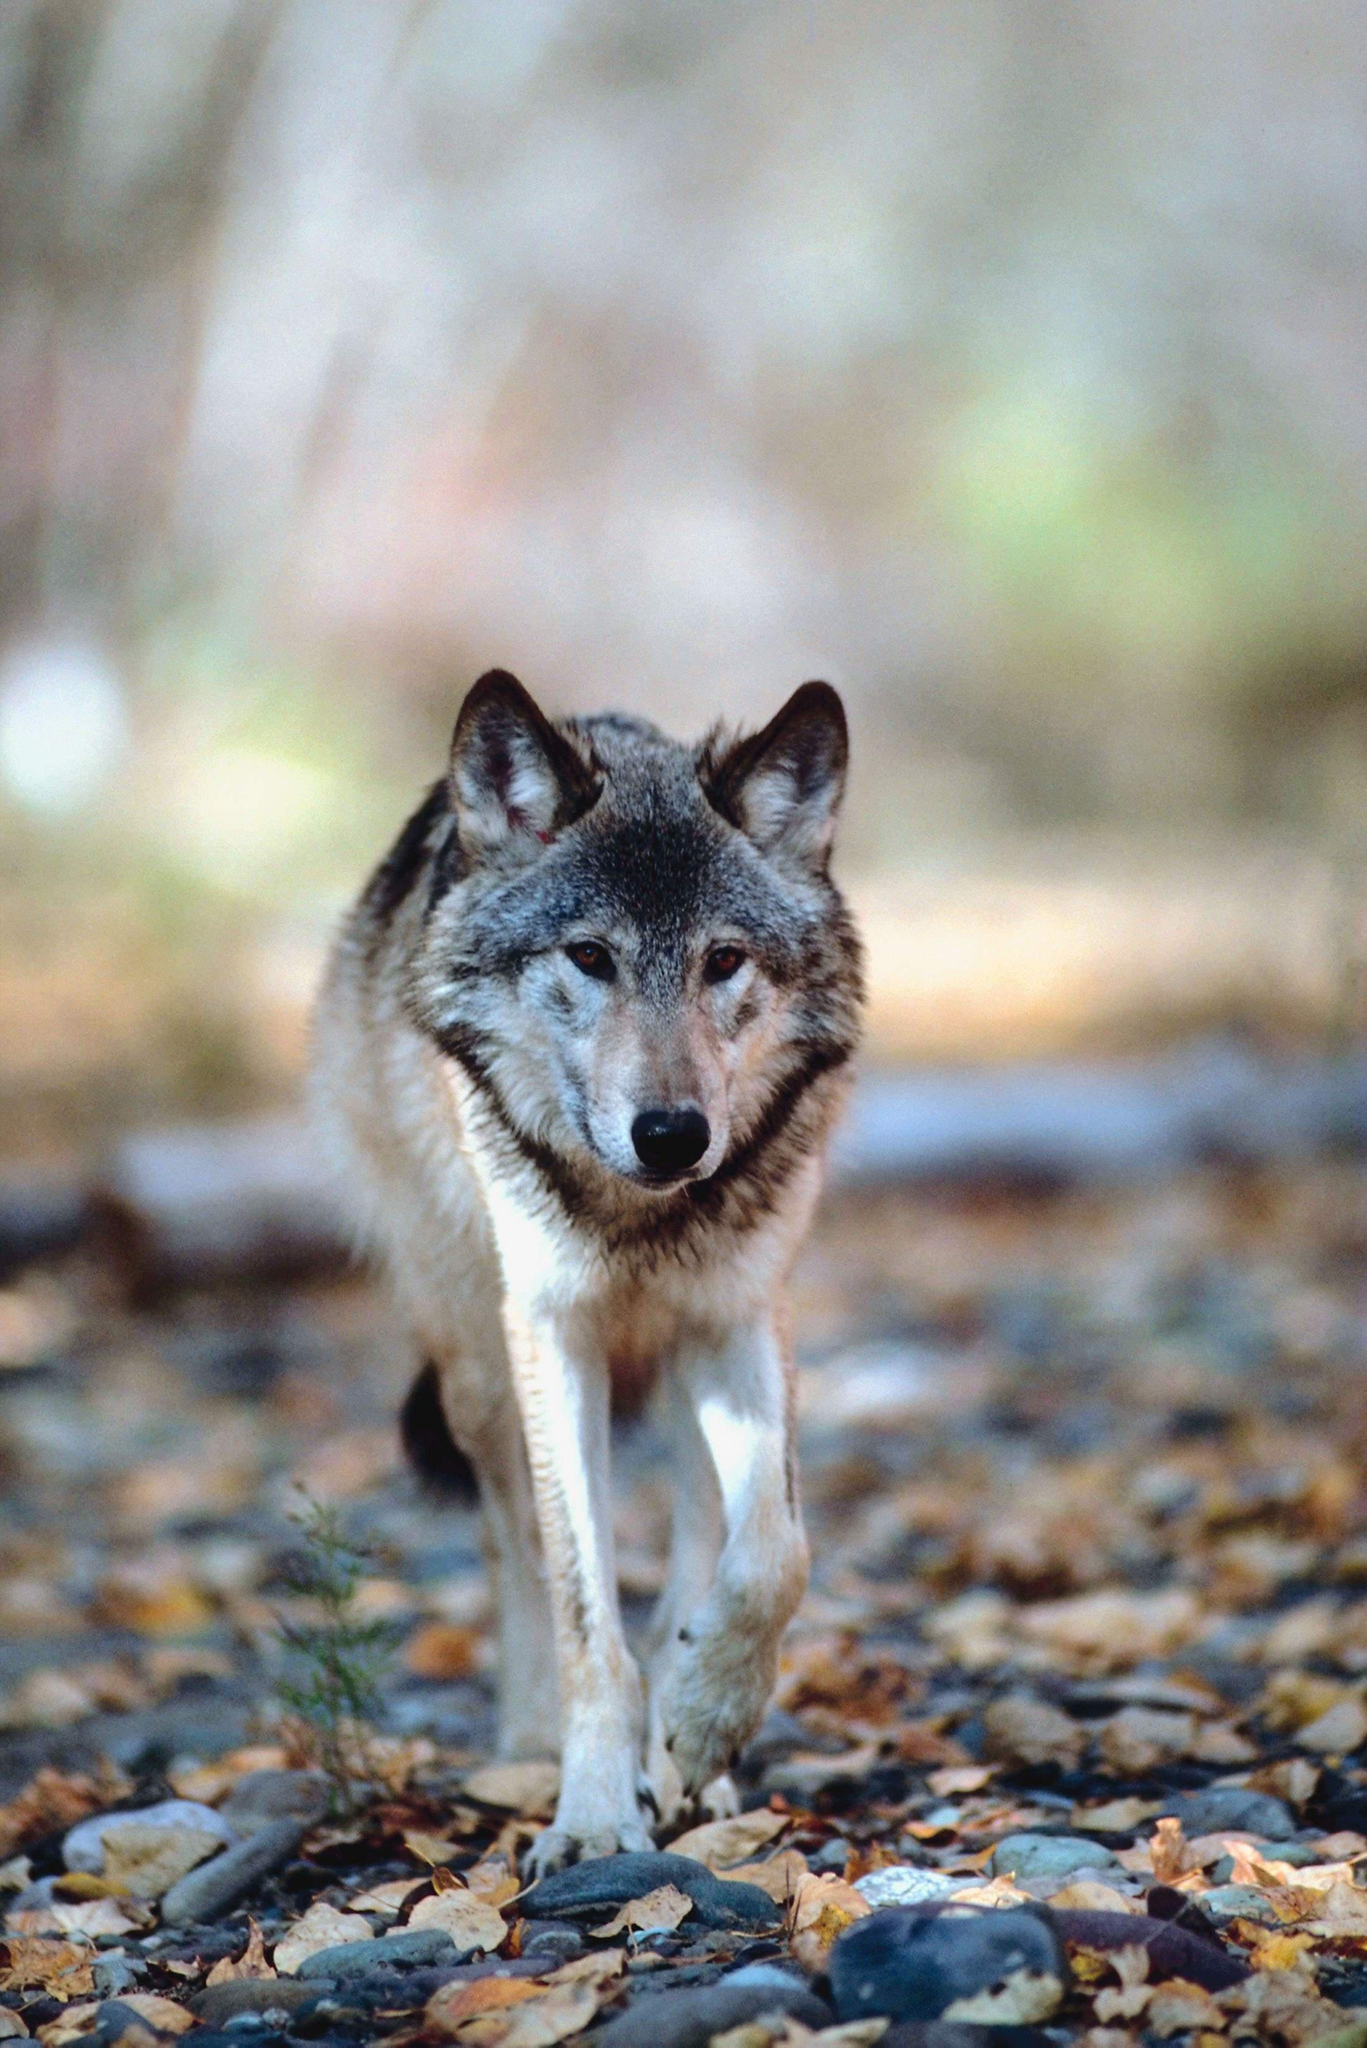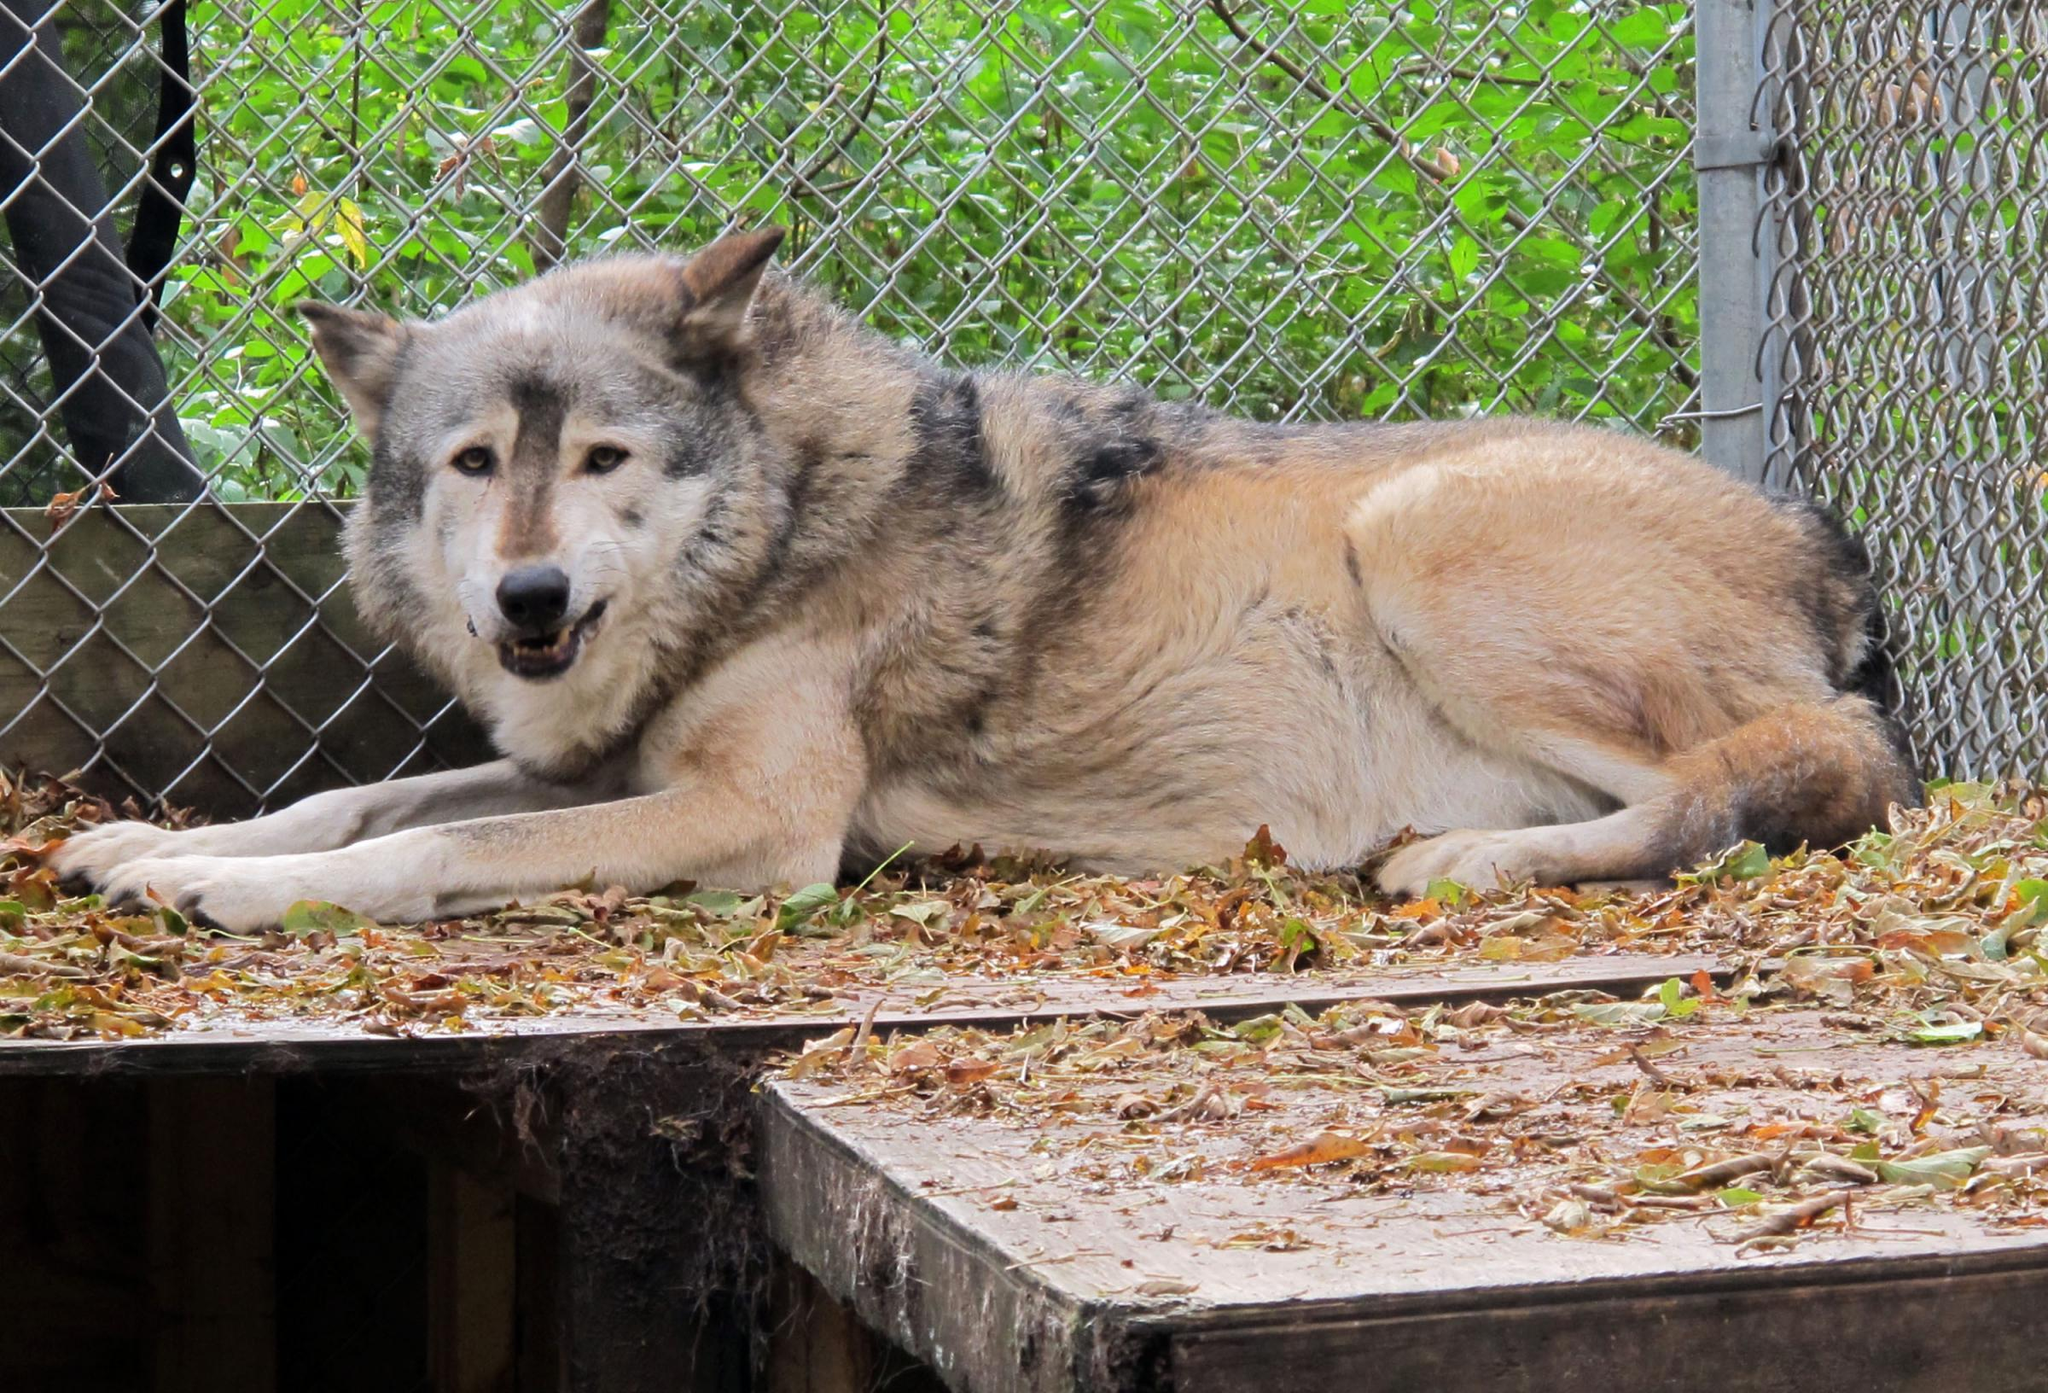The first image is the image on the left, the second image is the image on the right. Considering the images on both sides, is "The wolves are looking toward the camera." valid? Answer yes or no. Yes. The first image is the image on the left, the second image is the image on the right. Evaluate the accuracy of this statement regarding the images: "the wolves in the image pair are looking into the camera". Is it true? Answer yes or no. Yes. 